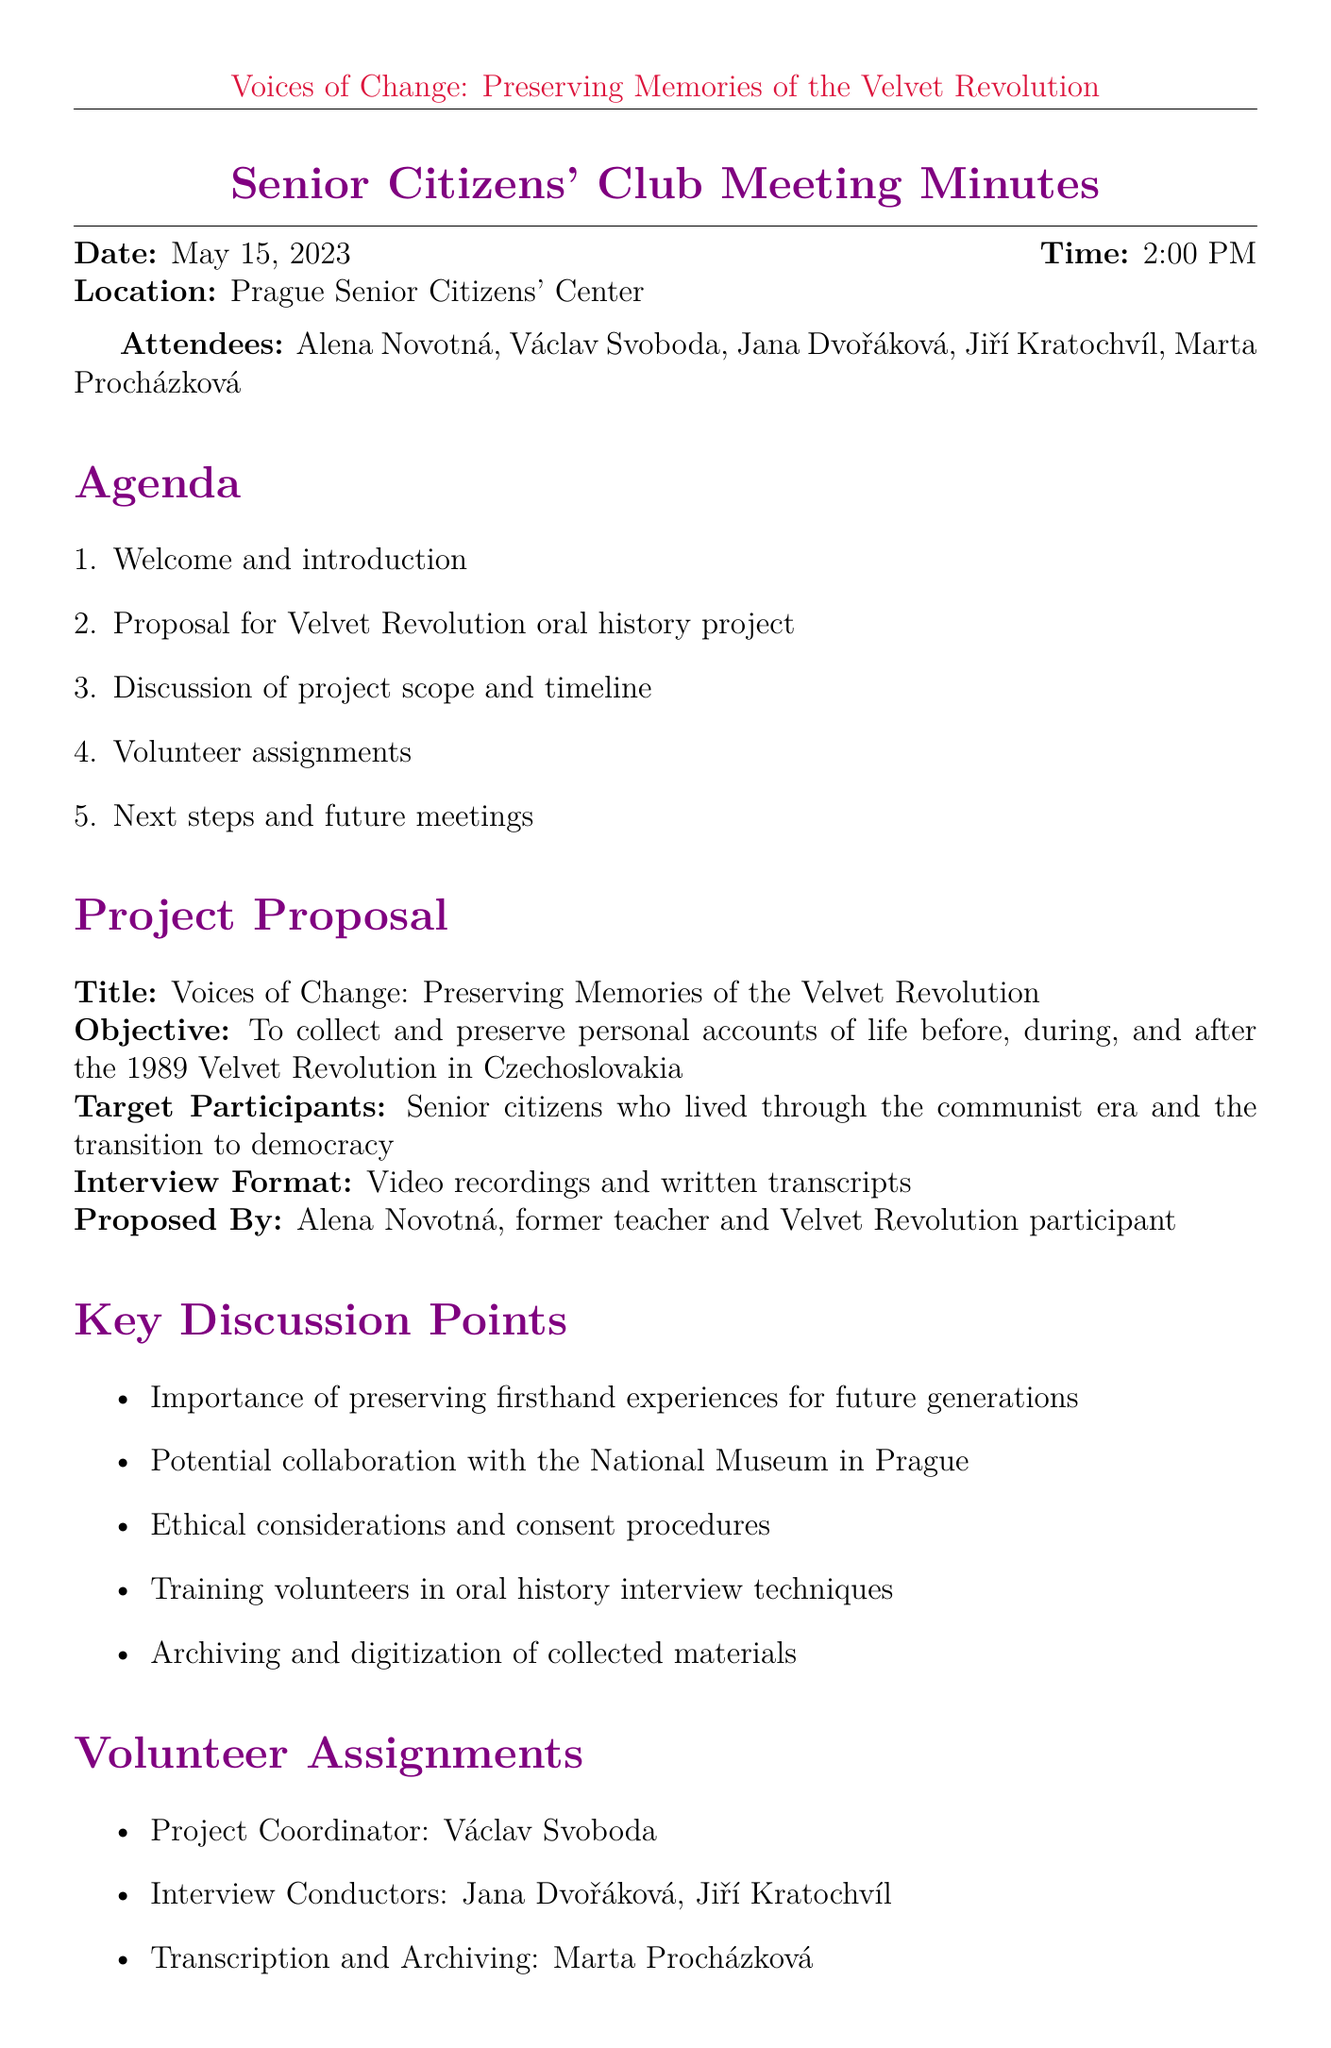What is the date of the meeting? The date of the meeting is explicitly mentioned in the document.
Answer: May 15, 2023 Who proposed the oral history project? The document states who originally proposed the project.
Answer: Alena Novotná What is the title of the project? The title is clearly listed in the project proposal section.
Answer: Voices of Change: Preserving Memories of the Velvet Revolution When does the interview phase begin? The document specifies the start of the interview phase in the timeline section.
Answer: September 2023 Who is the project coordinator? The volunteer assignments section indicates who the project coordinator is.
Answer: Václav Svoboda What is the purpose of this oral history project? The document outlines the objective of the project.
Answer: To collect and preserve personal accounts of life before, during, and after the 1989 Velvet Revolution in Czechoslovakia What is the public presentation date? The timeline specifies when the public presentation will occur.
Answer: November 17, 2024 What will be trained during the next meeting? The agenda for the next meeting lists the focus of the meeting.
Answer: Volunteer training 